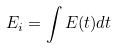Convert formula to latex. <formula><loc_0><loc_0><loc_500><loc_500>E _ { i } = \int E ( t ) d t</formula> 